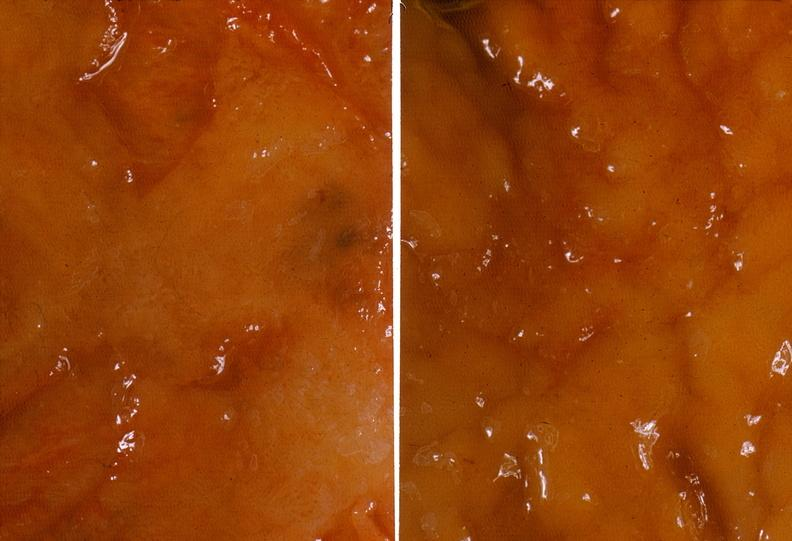s malignant lymphoma present?
Answer the question using a single word or phrase. No 